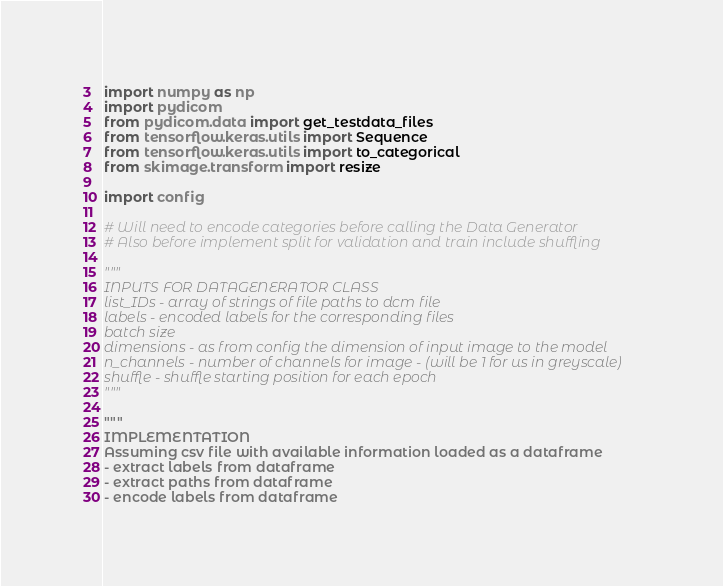Convert code to text. <code><loc_0><loc_0><loc_500><loc_500><_Python_>import numpy as np
import pydicom
from pydicom.data import get_testdata_files
from tensorflow.keras.utils import Sequence
from tensorflow.keras.utils import to_categorical
from skimage.transform import resize

import config

# Will need to encode categories before calling the Data Generator
# Also before implement split for validation and train include shuffling

"""
INPUTS FOR DATAGENERATOR CLASS
list_IDs - array of strings of file paths to dcm file 
labels - encoded labels for the corresponding files
batch size
dimensions - as from config the dimension of input image to the model
n_channels - number of channels for image - (will be 1 for us in greyscale)
shuffle - shuffle starting position for each epoch
"""

"""
IMPLEMENTATION
Assuming csv file with available information loaded as a dataframe
- extract labels from dataframe
- extract paths from dataframe
- encode labels from dataframe</code> 